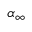<formula> <loc_0><loc_0><loc_500><loc_500>\ \alpha _ { \infty }</formula> 